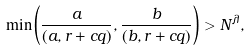<formula> <loc_0><loc_0><loc_500><loc_500>\min \left ( \frac { a } { ( a , r + c q ) } , \frac { b } { ( b , r + c q ) } \right ) > N ^ { \lambda } ,</formula> 